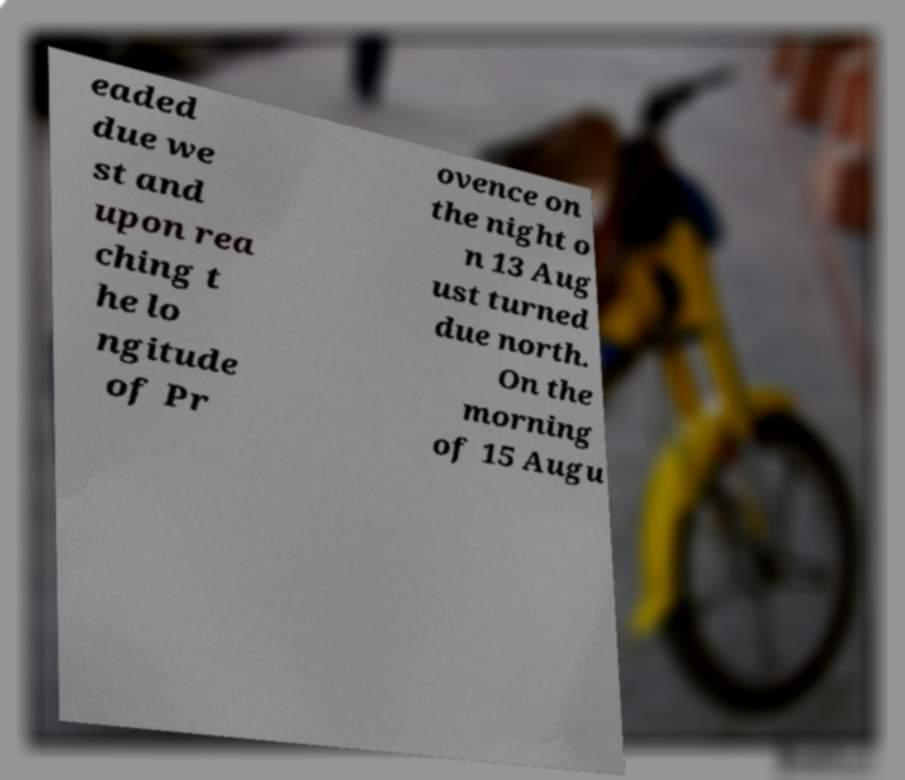I need the written content from this picture converted into text. Can you do that? eaded due we st and upon rea ching t he lo ngitude of Pr ovence on the night o n 13 Aug ust turned due north. On the morning of 15 Augu 